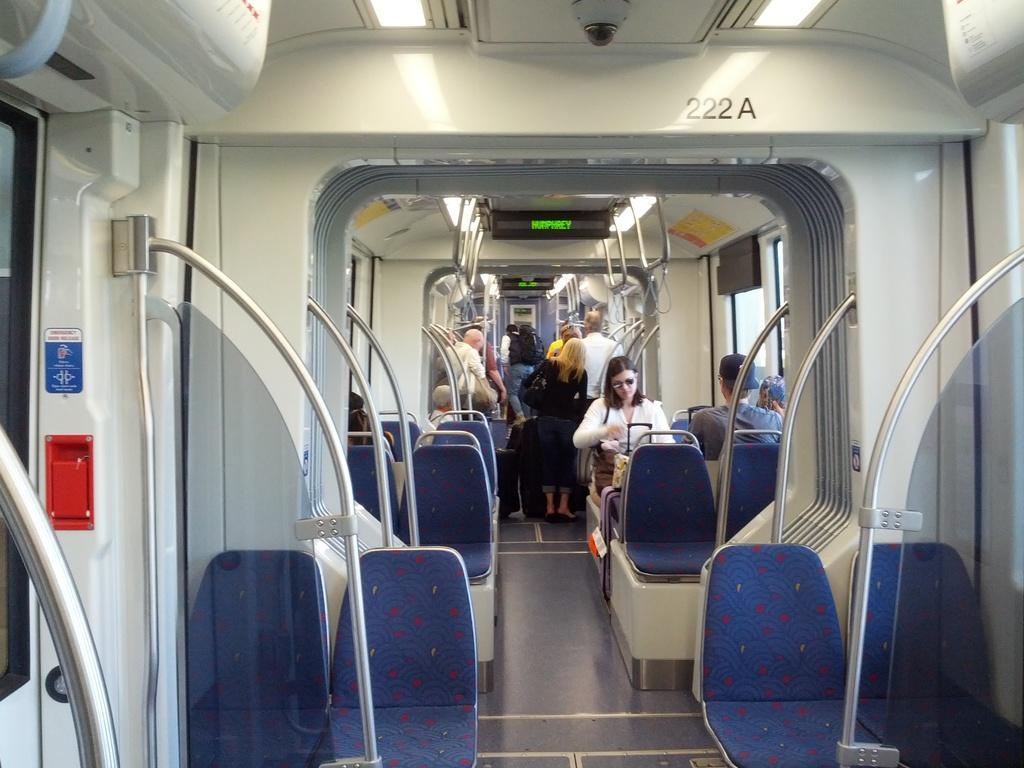Please provide a concise description of this image. In this image, we can see the interior view of a vehicle. We can see some people and poles. We can see a red colored object. We can see some chairs and the ground. We can also see some posters and screens. We can see the roof with some lights. 